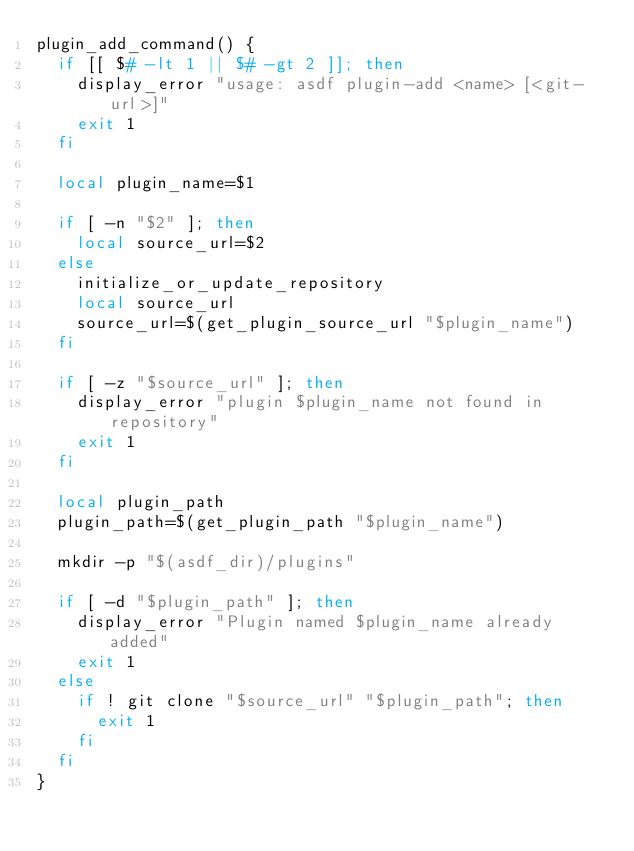Convert code to text. <code><loc_0><loc_0><loc_500><loc_500><_Bash_>plugin_add_command() {
  if [[ $# -lt 1 || $# -gt 2 ]]; then
    display_error "usage: asdf plugin-add <name> [<git-url>]"
    exit 1
  fi

  local plugin_name=$1

  if [ -n "$2" ]; then
    local source_url=$2
  else
    initialize_or_update_repository
    local source_url
    source_url=$(get_plugin_source_url "$plugin_name")
  fi

  if [ -z "$source_url" ]; then
    display_error "plugin $plugin_name not found in repository"
    exit 1
  fi

  local plugin_path
  plugin_path=$(get_plugin_path "$plugin_name")

  mkdir -p "$(asdf_dir)/plugins"

  if [ -d "$plugin_path" ]; then
    display_error "Plugin named $plugin_name already added"
    exit 1
  else
    if ! git clone "$source_url" "$plugin_path"; then
      exit 1
    fi
  fi
}
</code> 